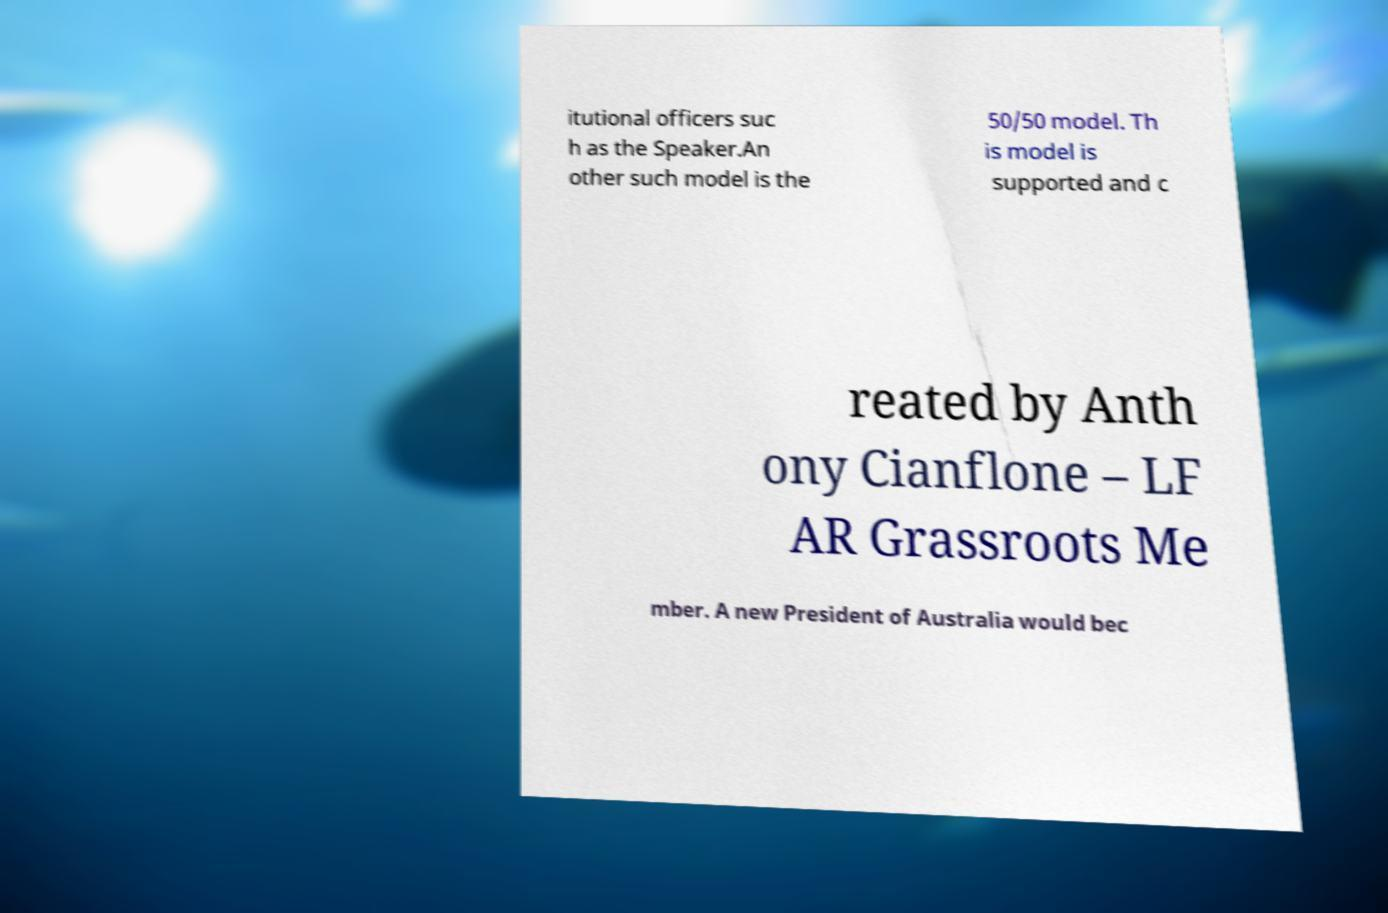What messages or text are displayed in this image? I need them in a readable, typed format. itutional officers suc h as the Speaker.An other such model is the 50/50 model. Th is model is supported and c reated by Anth ony Cianflone – LF AR Grassroots Me mber. A new President of Australia would bec 